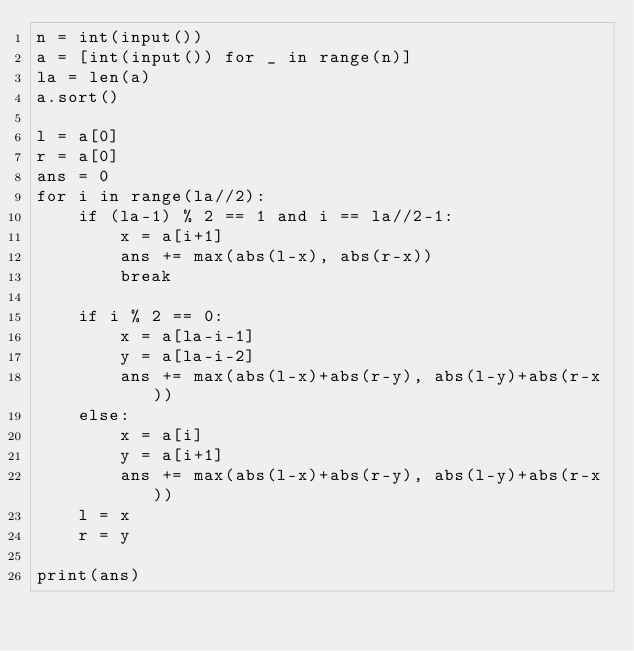<code> <loc_0><loc_0><loc_500><loc_500><_Python_>n = int(input())
a = [int(input()) for _ in range(n)]
la = len(a)
a.sort()

l = a[0]
r = a[0]
ans = 0
for i in range(la//2):
    if (la-1) % 2 == 1 and i == la//2-1:
        x = a[i+1]
        ans += max(abs(l-x), abs(r-x))
        break

    if i % 2 == 0:
        x = a[la-i-1]
        y = a[la-i-2]
        ans += max(abs(l-x)+abs(r-y), abs(l-y)+abs(r-x))
    else:
        x = a[i]
        y = a[i+1]
        ans += max(abs(l-x)+abs(r-y), abs(l-y)+abs(r-x))
    l = x
    r = y

print(ans)</code> 